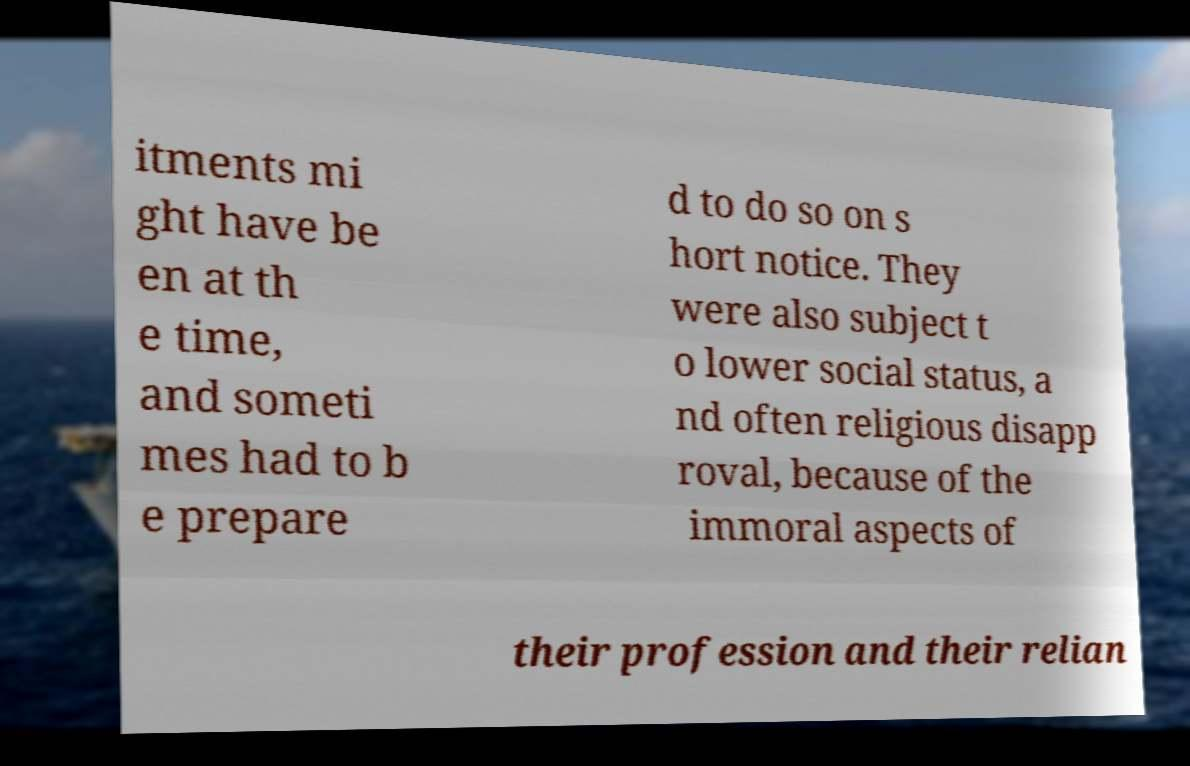Please read and relay the text visible in this image. What does it say? itments mi ght have be en at th e time, and someti mes had to b e prepare d to do so on s hort notice. They were also subject t o lower social status, a nd often religious disapp roval, because of the immoral aspects of their profession and their relian 